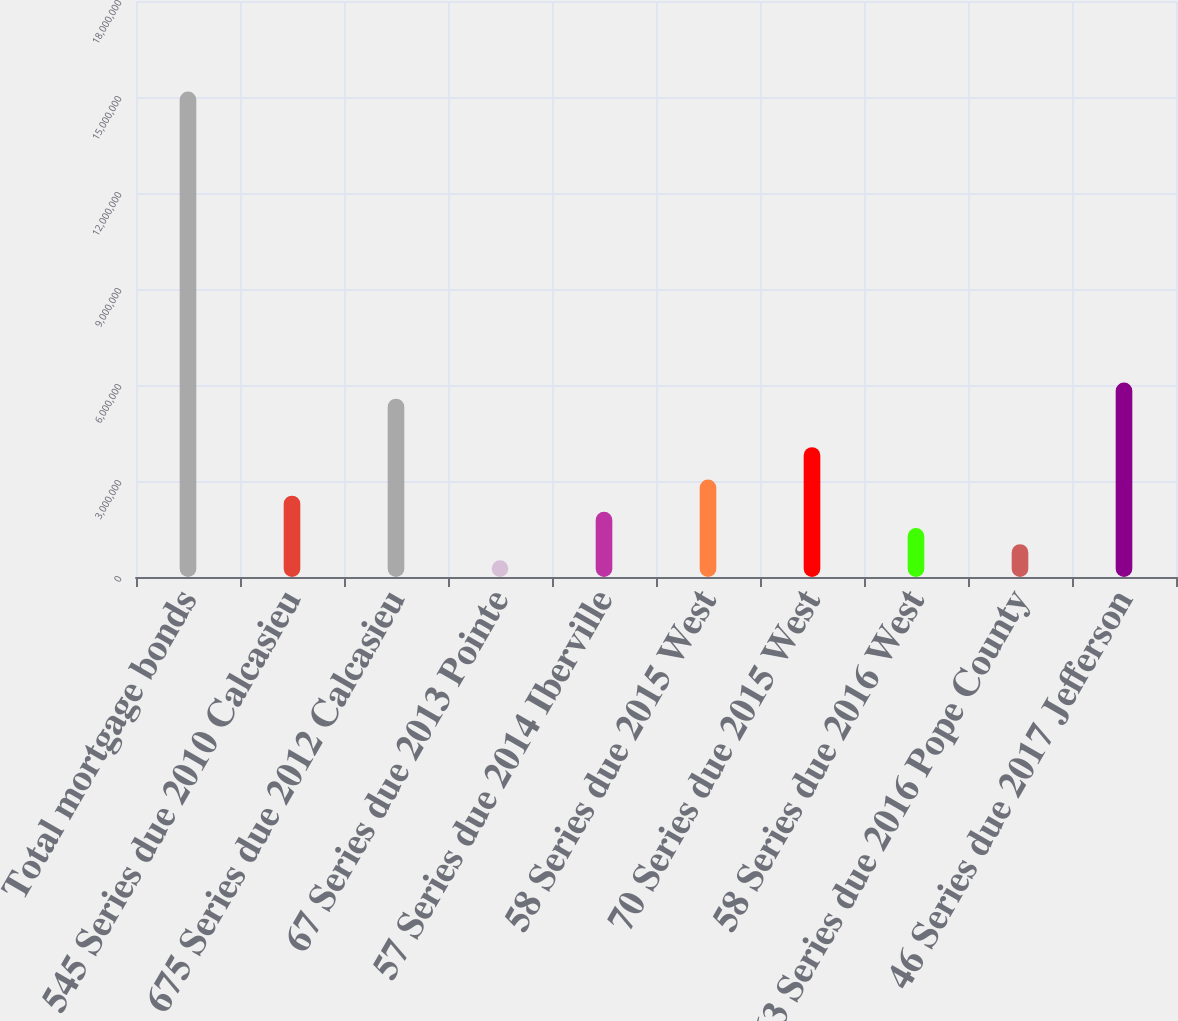<chart> <loc_0><loc_0><loc_500><loc_500><bar_chart><fcel>Total mortgage bonds<fcel>545 Series due 2010 Calcasieu<fcel>675 Series due 2012 Calcasieu<fcel>67 Series due 2013 Pointe<fcel>57 Series due 2014 Iberville<fcel>58 Series due 2015 West<fcel>70 Series due 2015 West<fcel>58 Series due 2016 West<fcel>63 Series due 2016 Pope County<fcel>46 Series due 2017 Jefferson<nl><fcel>1.51727e+07<fcel>2.54214e+06<fcel>5.57347e+06<fcel>521252<fcel>2.03692e+06<fcel>3.04736e+06<fcel>4.0578e+06<fcel>1.53169e+06<fcel>1.02647e+06<fcel>6.07869e+06<nl></chart> 